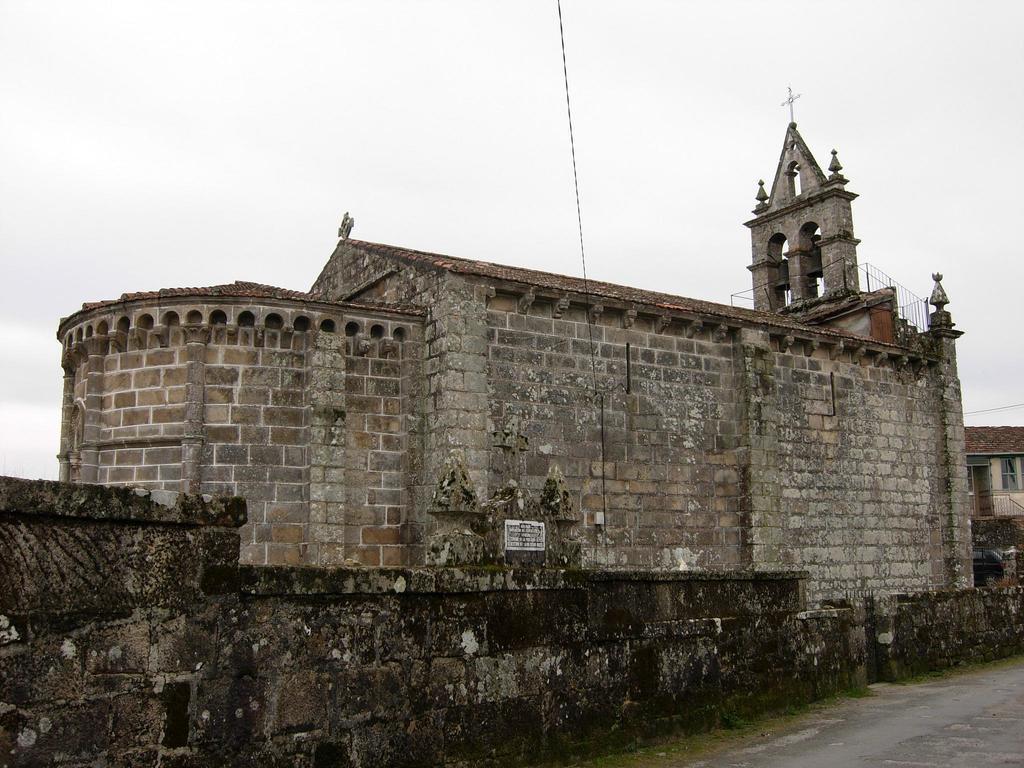Can you describe this image briefly? In this image we can see a building with the railing and a cross. We can also see the pathway and the sky which looks cloudy. 